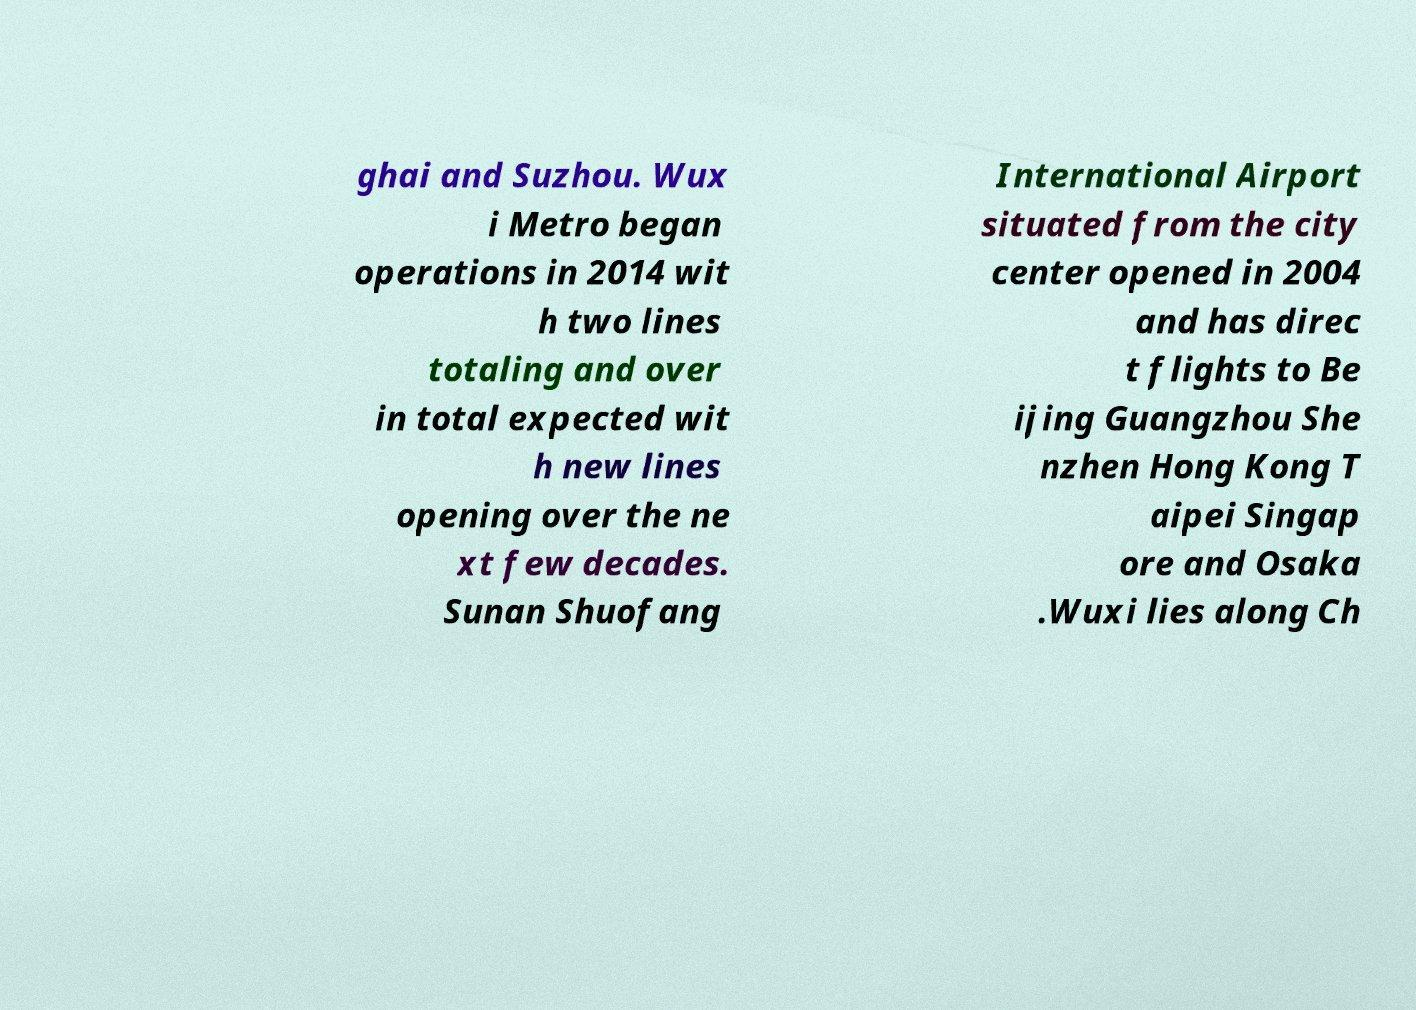What messages or text are displayed in this image? I need them in a readable, typed format. ghai and Suzhou. Wux i Metro began operations in 2014 wit h two lines totaling and over in total expected wit h new lines opening over the ne xt few decades. Sunan Shuofang International Airport situated from the city center opened in 2004 and has direc t flights to Be ijing Guangzhou She nzhen Hong Kong T aipei Singap ore and Osaka .Wuxi lies along Ch 